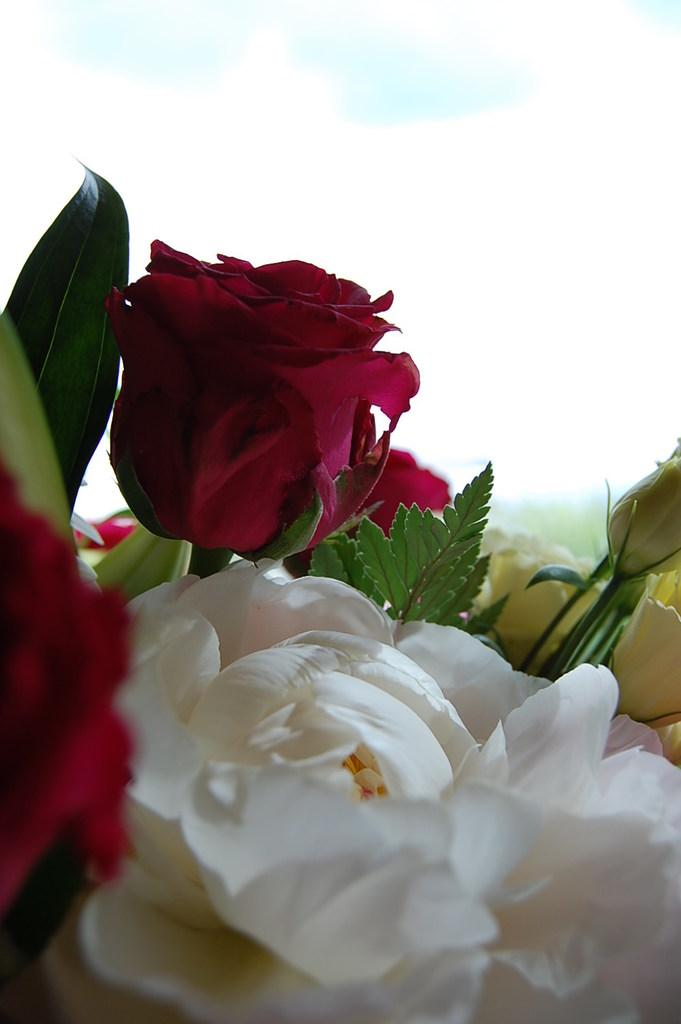What type of plants can be seen in the image? There are flowers in the image. What colors are the flowers? The flowers are red, white, and yellow in color. What else can be seen in the image besides flowers? There are leaves in the image. What color are the leaves? The leaves are green in color. What is visible in the background of the image? The sky is visible in the background of the image. How long does it take for the flowers to make a wish in the image? There is no indication in the image that the flowers are capable of making wishes, so it cannot be determined from the image. 